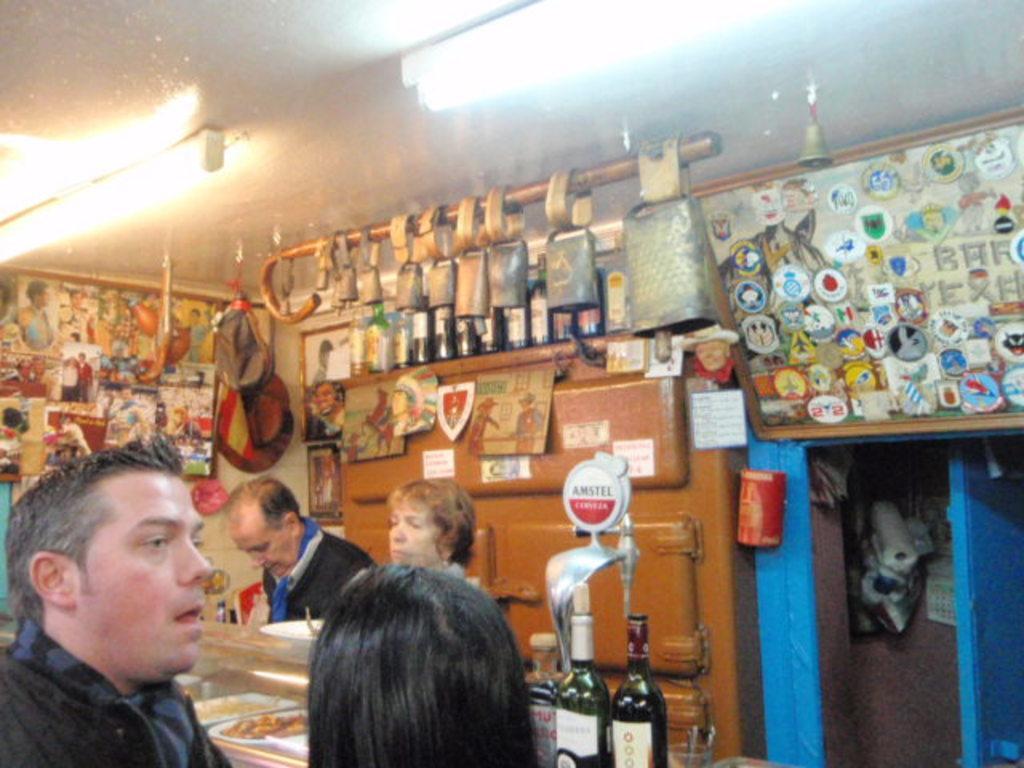In one or two sentences, can you explain what this image depicts? In this image, we can see people standing and in the background, there are objects hanging and we can see a board, papers and some posts are placed on the wall and there are some bottles, bags are also there. On the right, there is a rack. At the bottom, there is food inside the stand. At the top, there are lights and there is a roof and we can see a bell. 